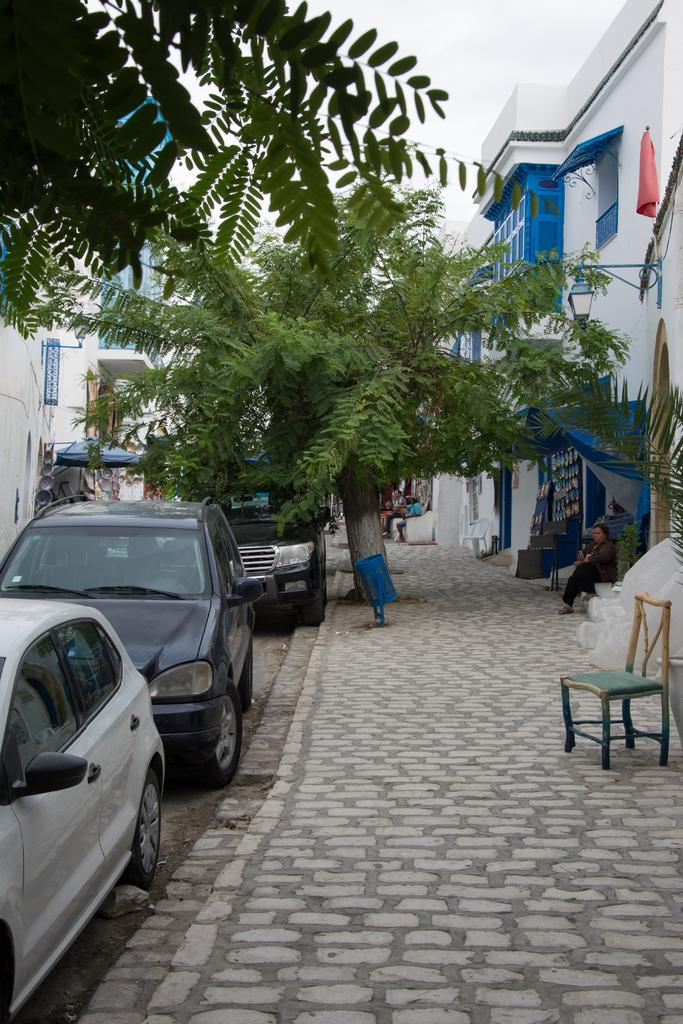What is the person in the image doing? There is a person sitting in the image. What can be seen in the background of the image? There are cars, trees, buildings, and the sky visible in the image. What type of furniture is present in the image? There is a chair in the image. Are there any other people visible in the image? Yes, there are people visible in the distance. What color is the boy's shirt in the image? There is no boy present in the image, and therefore no shirt to describe. 